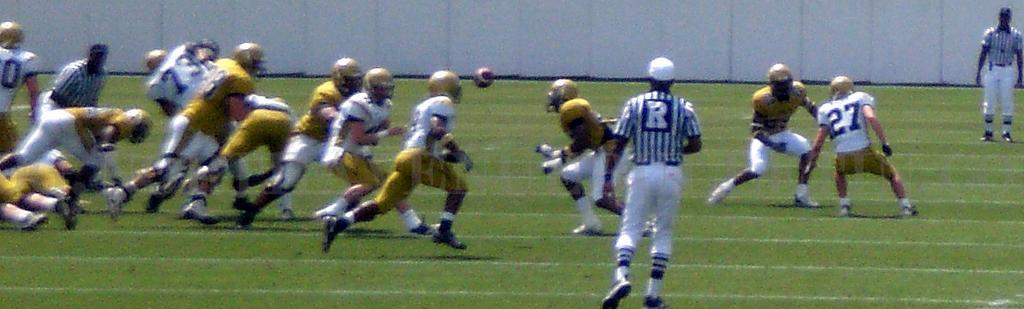Please provide a concise description of this image. This picture is clicked outside. In the center there is a person wearing t-shirt and seems to be running on the ground. In the center we can see the group of persons wearing t-shirts, helmets, running on the ground and playing some game. In the background we can see a ball and a white color object seems to be the wall. 